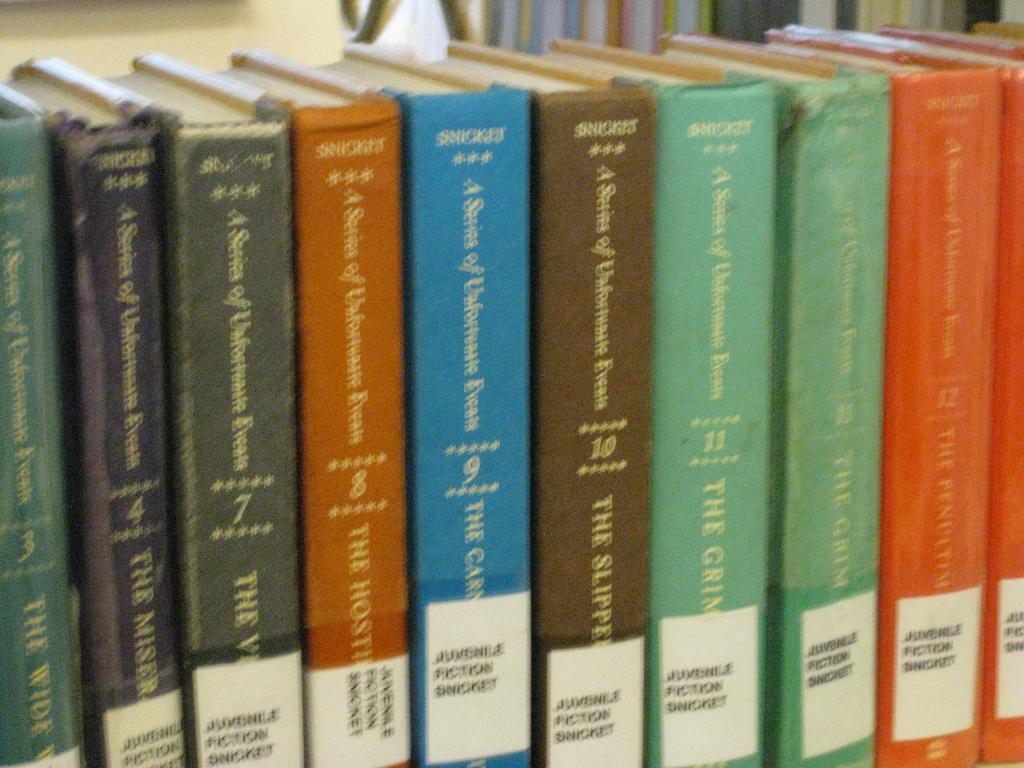What kind of fiction is featured here?
Provide a succinct answer. Juvenile. What is one number on one of the books?
Give a very brief answer. 3. 